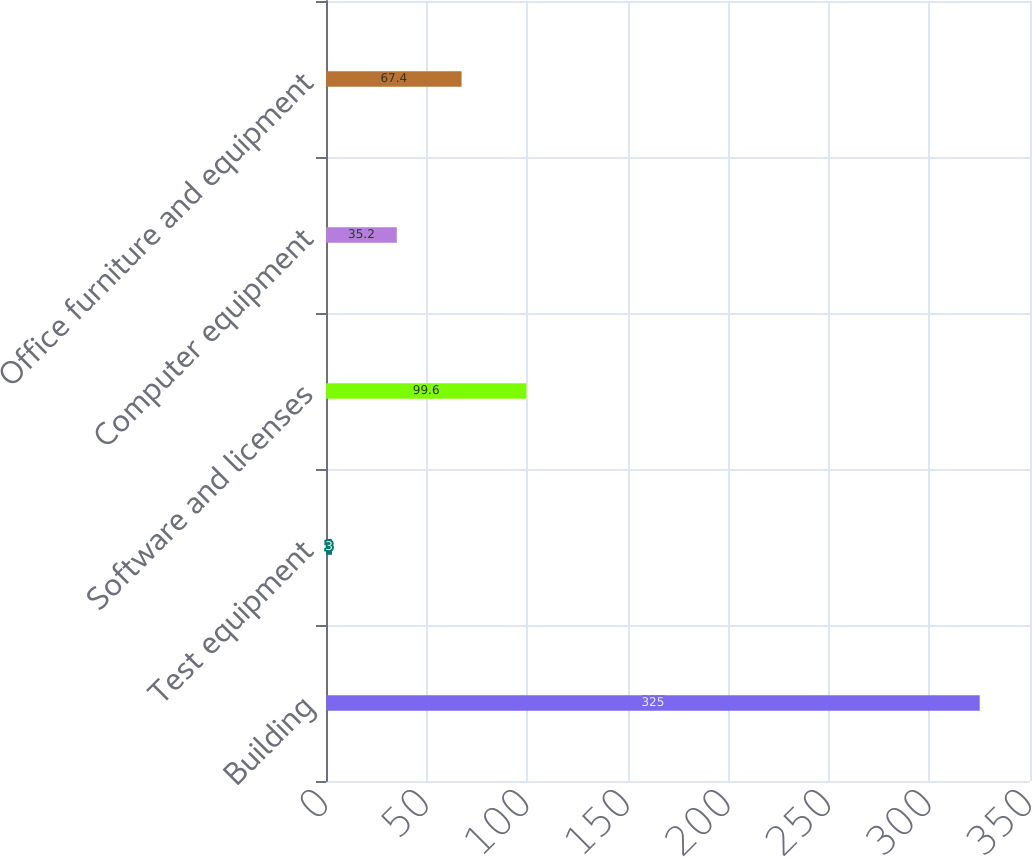Convert chart to OTSL. <chart><loc_0><loc_0><loc_500><loc_500><bar_chart><fcel>Building<fcel>Test equipment<fcel>Software and licenses<fcel>Computer equipment<fcel>Office furniture and equipment<nl><fcel>325<fcel>3<fcel>99.6<fcel>35.2<fcel>67.4<nl></chart> 